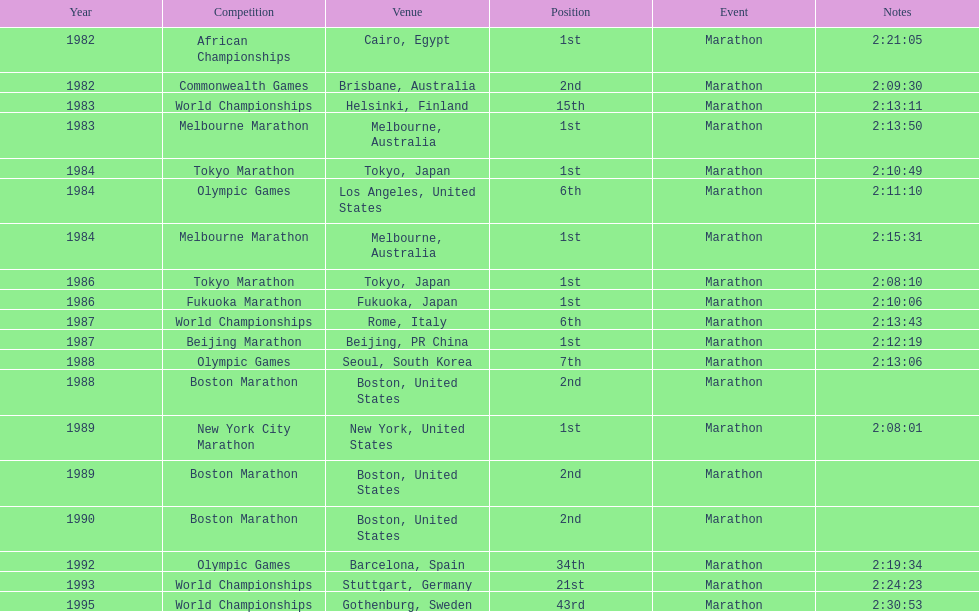What is the total count of 1st place wins? 8. 